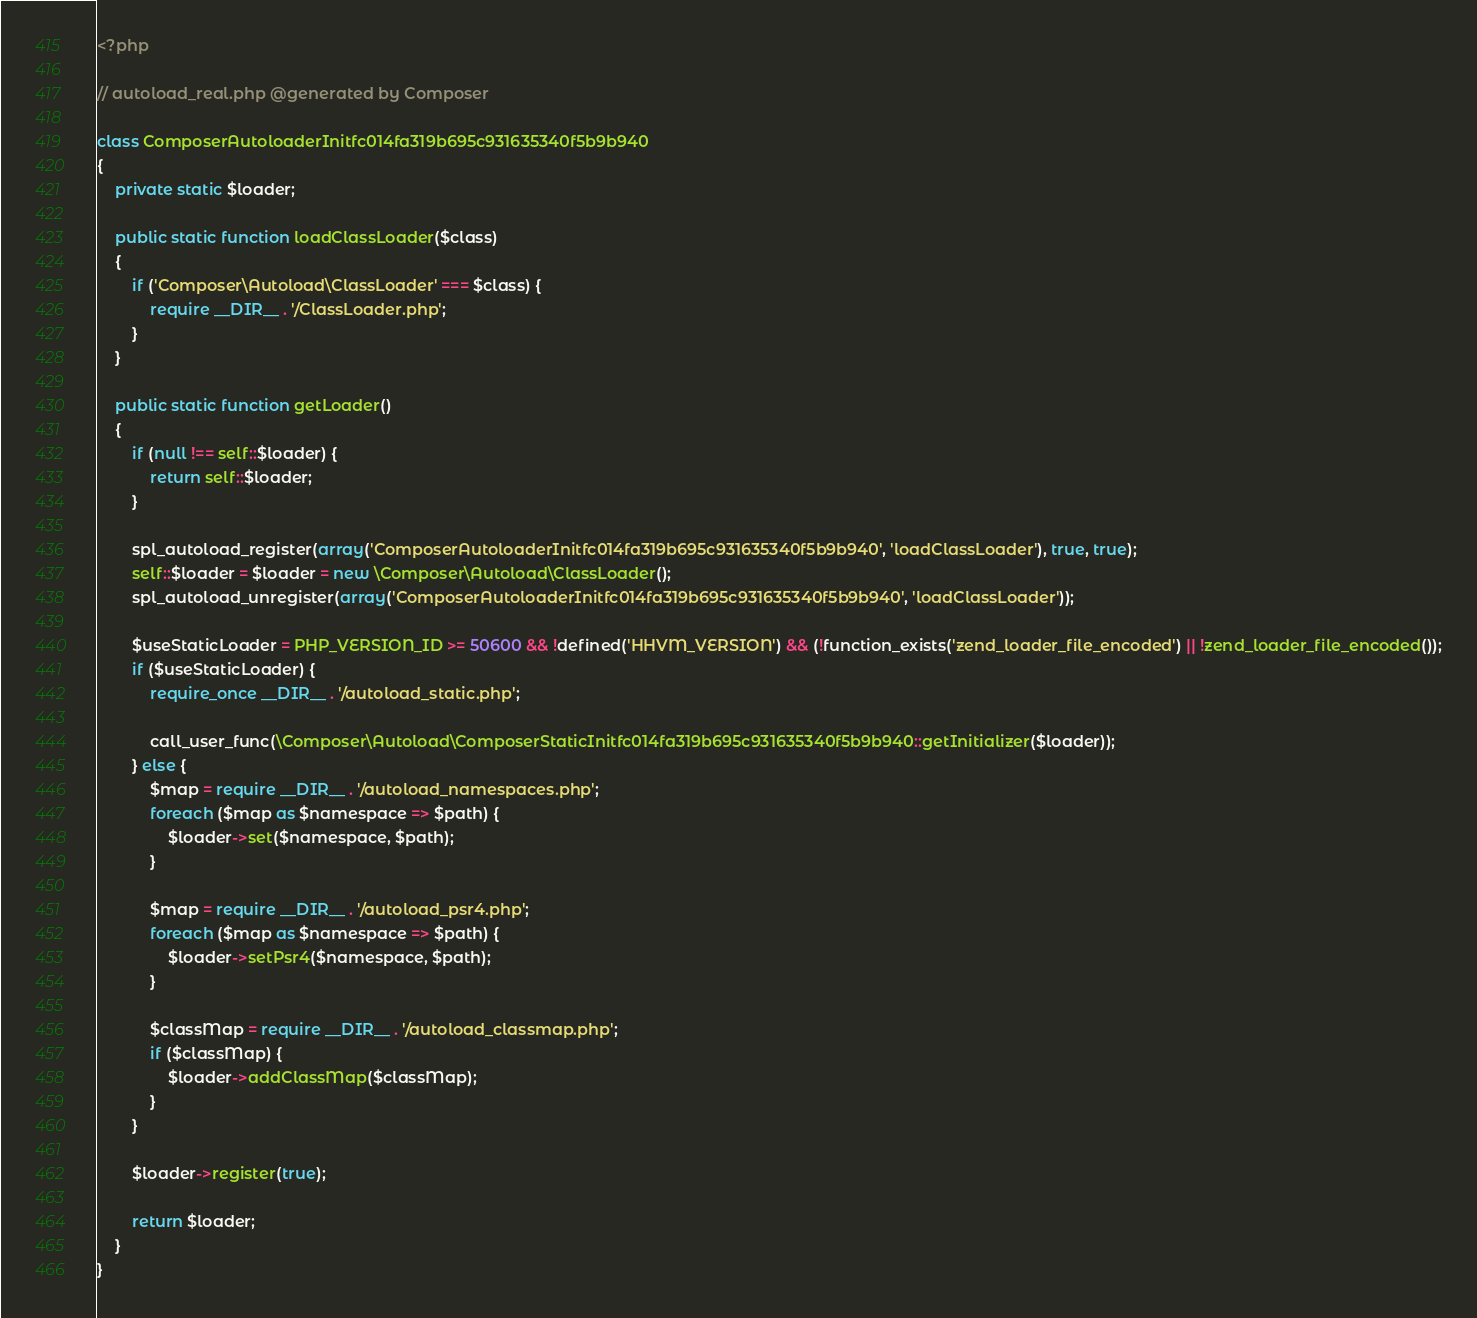Convert code to text. <code><loc_0><loc_0><loc_500><loc_500><_PHP_><?php

// autoload_real.php @generated by Composer

class ComposerAutoloaderInitfc014fa319b695c931635340f5b9b940
{
    private static $loader;

    public static function loadClassLoader($class)
    {
        if ('Composer\Autoload\ClassLoader' === $class) {
            require __DIR__ . '/ClassLoader.php';
        }
    }

    public static function getLoader()
    {
        if (null !== self::$loader) {
            return self::$loader;
        }

        spl_autoload_register(array('ComposerAutoloaderInitfc014fa319b695c931635340f5b9b940', 'loadClassLoader'), true, true);
        self::$loader = $loader = new \Composer\Autoload\ClassLoader();
        spl_autoload_unregister(array('ComposerAutoloaderInitfc014fa319b695c931635340f5b9b940', 'loadClassLoader'));

        $useStaticLoader = PHP_VERSION_ID >= 50600 && !defined('HHVM_VERSION') && (!function_exists('zend_loader_file_encoded') || !zend_loader_file_encoded());
        if ($useStaticLoader) {
            require_once __DIR__ . '/autoload_static.php';

            call_user_func(\Composer\Autoload\ComposerStaticInitfc014fa319b695c931635340f5b9b940::getInitializer($loader));
        } else {
            $map = require __DIR__ . '/autoload_namespaces.php';
            foreach ($map as $namespace => $path) {
                $loader->set($namespace, $path);
            }

            $map = require __DIR__ . '/autoload_psr4.php';
            foreach ($map as $namespace => $path) {
                $loader->setPsr4($namespace, $path);
            }

            $classMap = require __DIR__ . '/autoload_classmap.php';
            if ($classMap) {
                $loader->addClassMap($classMap);
            }
        }

        $loader->register(true);

        return $loader;
    }
}
</code> 